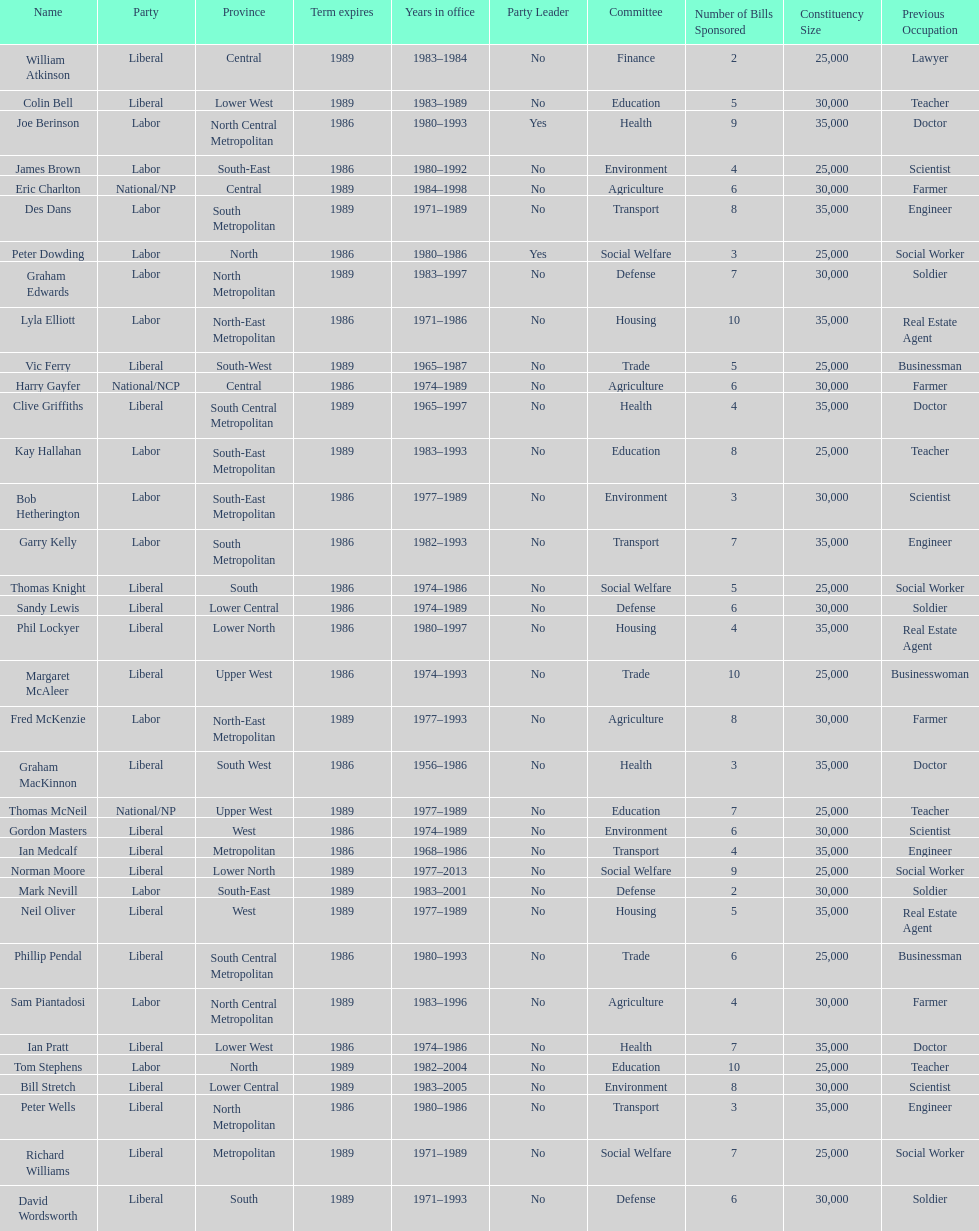What was phil lockyer's party? Liberal. 